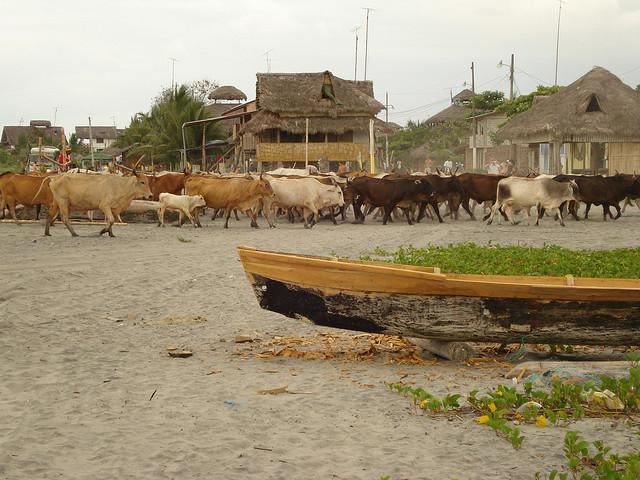What roofing method was used on these houses? thatch 